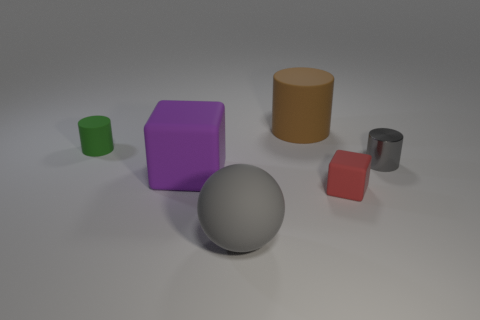Is there anything else that is made of the same material as the gray cylinder?
Your answer should be very brief. No. The cylinder that is the same size as the purple rubber object is what color?
Your answer should be compact. Brown. Are there any tiny things of the same color as the sphere?
Provide a short and direct response. Yes. Is the number of gray spheres that are behind the tiny gray object less than the number of gray objects to the left of the red rubber block?
Keep it short and to the point. Yes. There is a tiny object that is behind the tiny cube and right of the big purple rubber thing; what is its material?
Ensure brevity in your answer.  Metal. Do the large purple matte thing and the small matte object that is on the right side of the brown matte cylinder have the same shape?
Your response must be concise. Yes. Is the number of small red rubber blocks greater than the number of brown blocks?
Ensure brevity in your answer.  Yes. What number of large things are on the left side of the matte sphere and to the right of the gray rubber thing?
Ensure brevity in your answer.  0. There is a small rubber object right of the thing in front of the tiny rubber object to the right of the large gray object; what is its shape?
Your answer should be compact. Cube. Is there any other thing that is the same shape as the gray matte object?
Provide a short and direct response. No. 